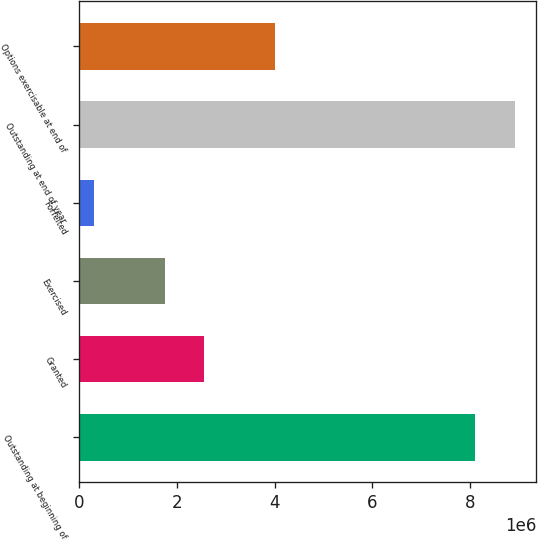<chart> <loc_0><loc_0><loc_500><loc_500><bar_chart><fcel>Outstanding at beginning of<fcel>Granted<fcel>Exercised<fcel>Forfeited<fcel>Outstanding at end of year<fcel>Options exercisable at end of<nl><fcel>8.10289e+06<fcel>2.55771e+06<fcel>1.74733e+06<fcel>302729<fcel>8.91327e+06<fcel>4.00116e+06<nl></chart> 